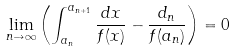Convert formula to latex. <formula><loc_0><loc_0><loc_500><loc_500>\lim _ { n \to \infty } \left ( \int _ { a _ { n } } ^ { a _ { n + 1 } } \frac { d x } { f ( x ) } - \frac { d _ { n } } { f ( a _ { n } ) } \right ) = 0</formula> 